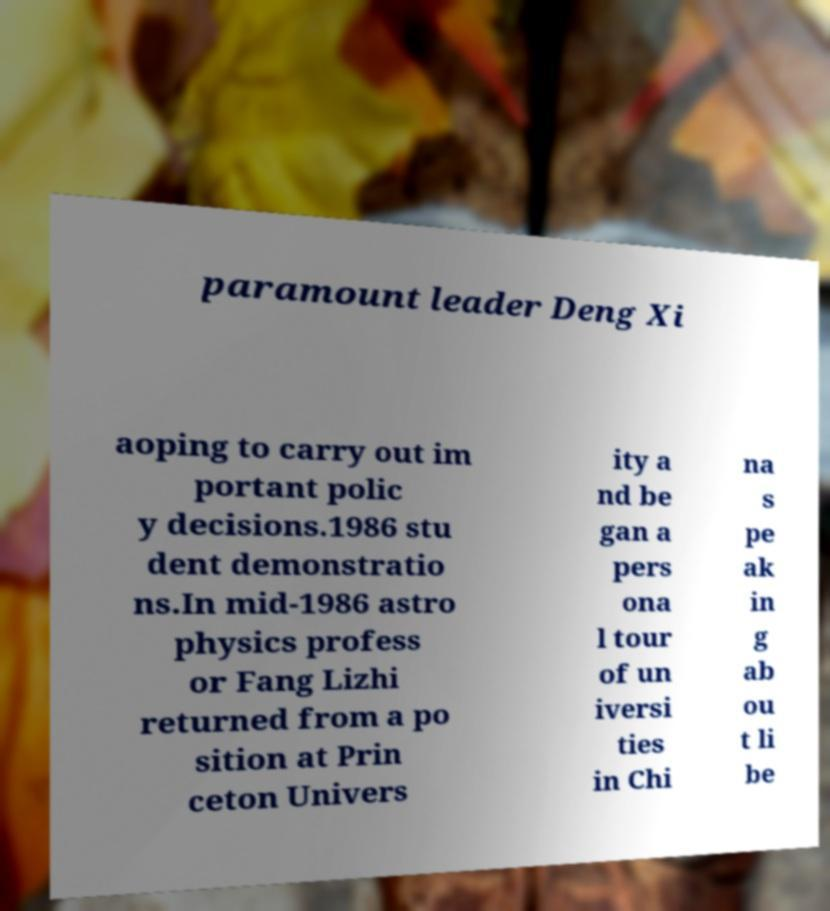Please read and relay the text visible in this image. What does it say? paramount leader Deng Xi aoping to carry out im portant polic y decisions.1986 stu dent demonstratio ns.In mid-1986 astro physics profess or Fang Lizhi returned from a po sition at Prin ceton Univers ity a nd be gan a pers ona l tour of un iversi ties in Chi na s pe ak in g ab ou t li be 